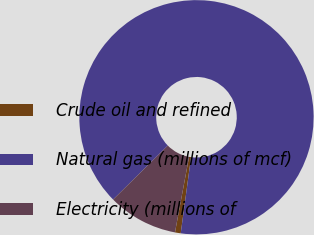Convert chart to OTSL. <chart><loc_0><loc_0><loc_500><loc_500><pie_chart><fcel>Crude oil and refined<fcel>Natural gas (millions of mcf)<fcel>Electricity (millions of<nl><fcel>0.79%<fcel>89.54%<fcel>9.67%<nl></chart> 